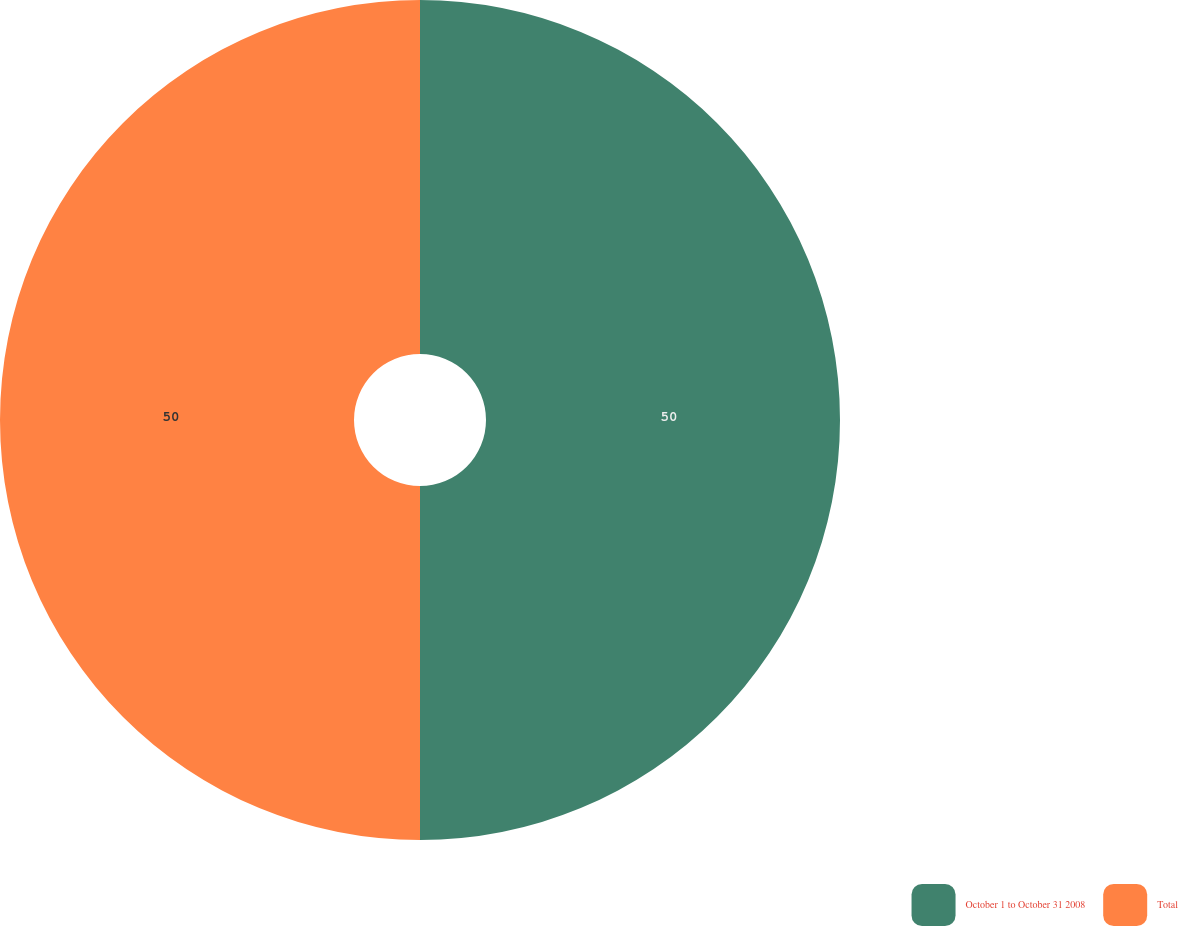Convert chart to OTSL. <chart><loc_0><loc_0><loc_500><loc_500><pie_chart><fcel>October 1 to October 31 2008<fcel>Total<nl><fcel>50.0%<fcel>50.0%<nl></chart> 